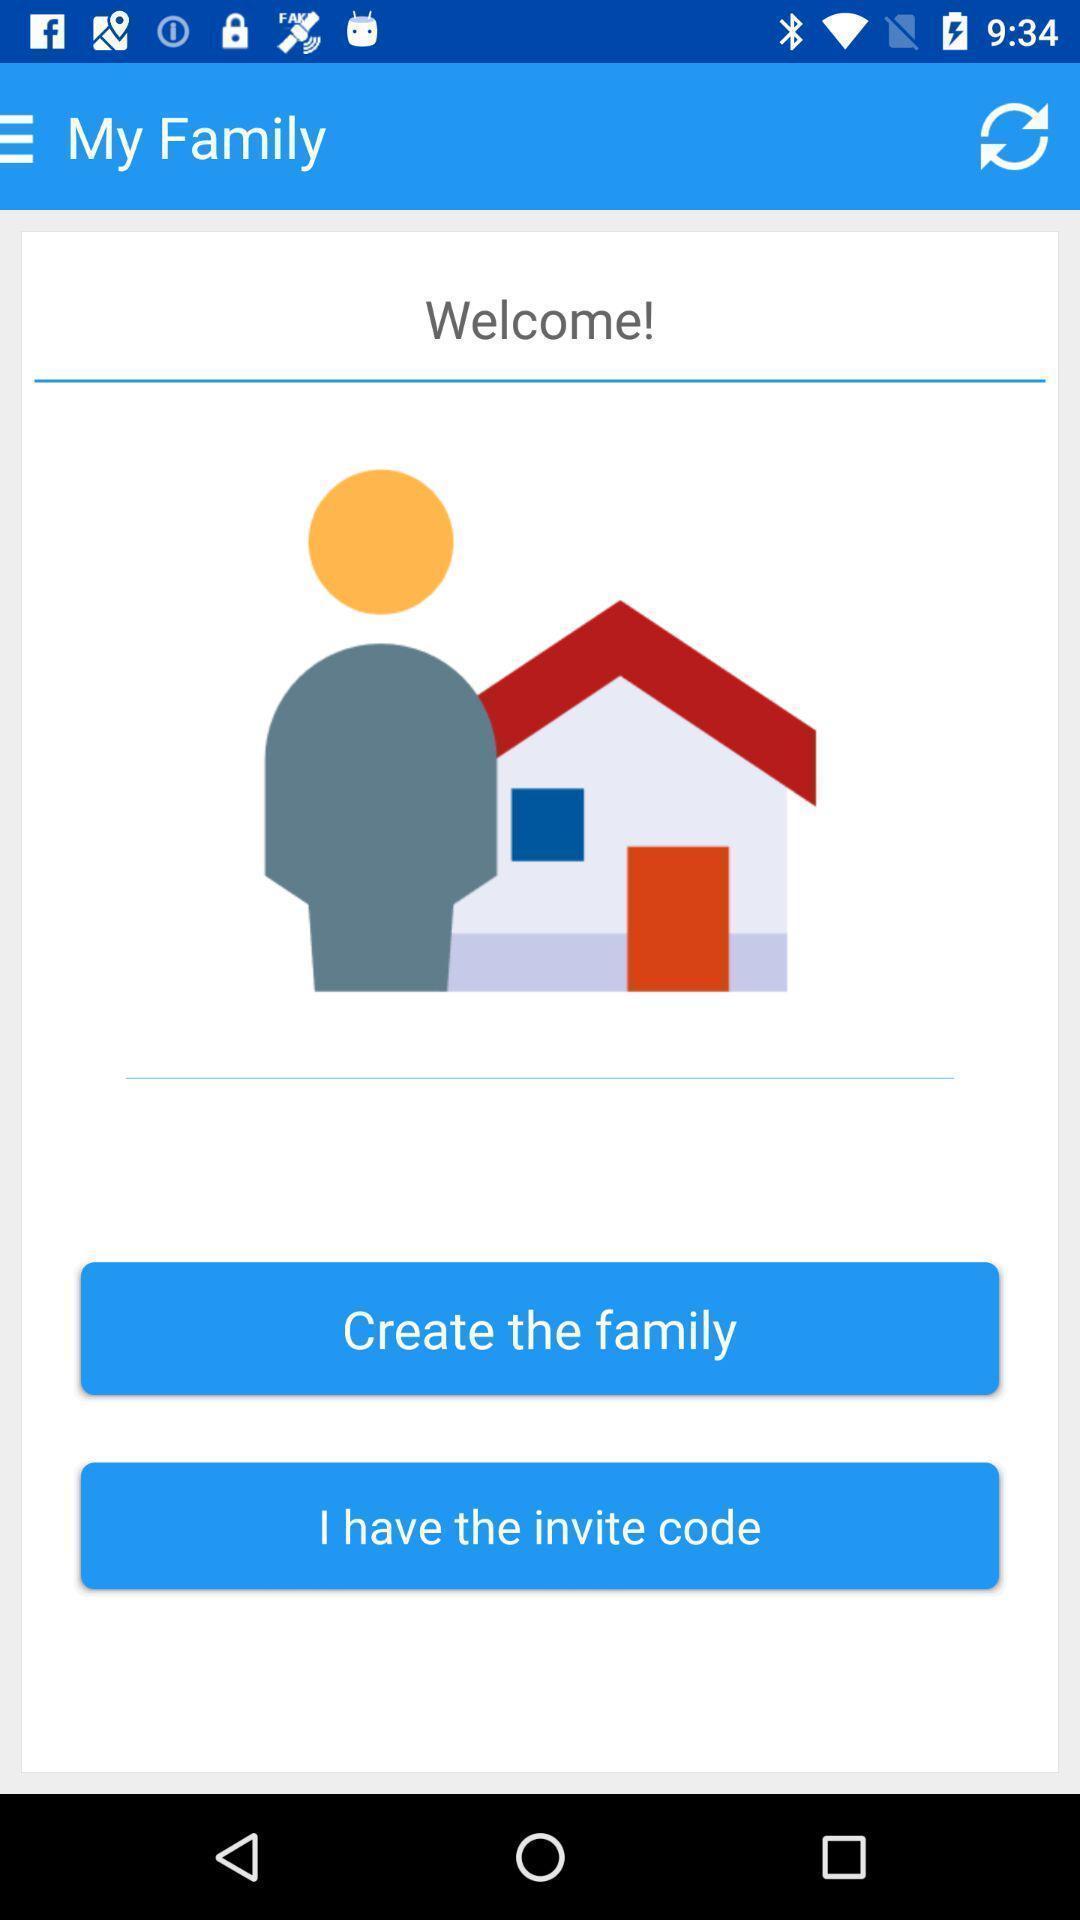Explain the elements present in this screenshot. Welcome page. 